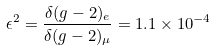Convert formula to latex. <formula><loc_0><loc_0><loc_500><loc_500>\epsilon ^ { 2 } = \frac { \delta ( g - 2 ) _ { e } } { \delta ( g - 2 ) _ { \mu } } = 1 . 1 \times 1 0 ^ { - 4 }</formula> 